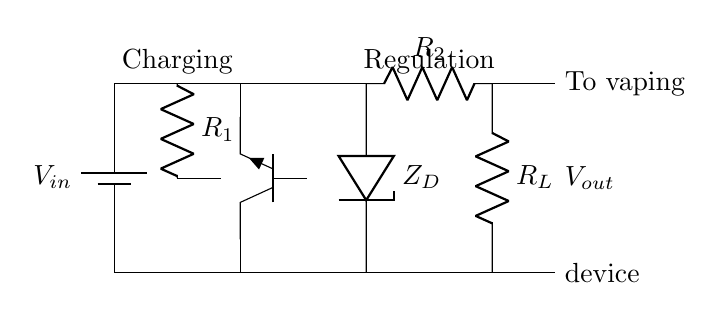What is the type of battery shown in the circuit? The circuit diagram shows a battery labeled as V-in, which is a source component used for charging the device.
Answer: Battery What is the purpose of the resistor labeled R1? R1 is part of the charging circuit, and its purpose is to limit the current flowing into the circuit to ensure safe charging of the battery.
Answer: Current limiting What does the component labeled ZD represent? ZD is a Zener diode, used in the voltage regulation part of the circuit to maintain a constant output voltage despite variations in load current.
Answer: Zener diode How many resistors are present in the circuit? There are three resistors shown in the circuit: R1, R2, and RL. These are used for current limiting and load resistance.
Answer: Three What is the function of the component labeled Q1? Q1 is a transistor that acts as a switch or amplifier in the charging circuit, controlling the current flow based on input conditions.
Answer: Transistor switch Why is voltage regulation important in this circuit? Voltage regulation is crucial to ensure that the output voltage remains stable and safe for the vaping device, preventing damage from voltage fluctuations.
Answer: Stability and safety What is the output voltage taken from in this circuit? The output voltage, labeled as V-out, is taken from the point after the Zener diode and resistor RL, which ensures the voltage delivered to the vaping device is regulated.
Answer: V-out 